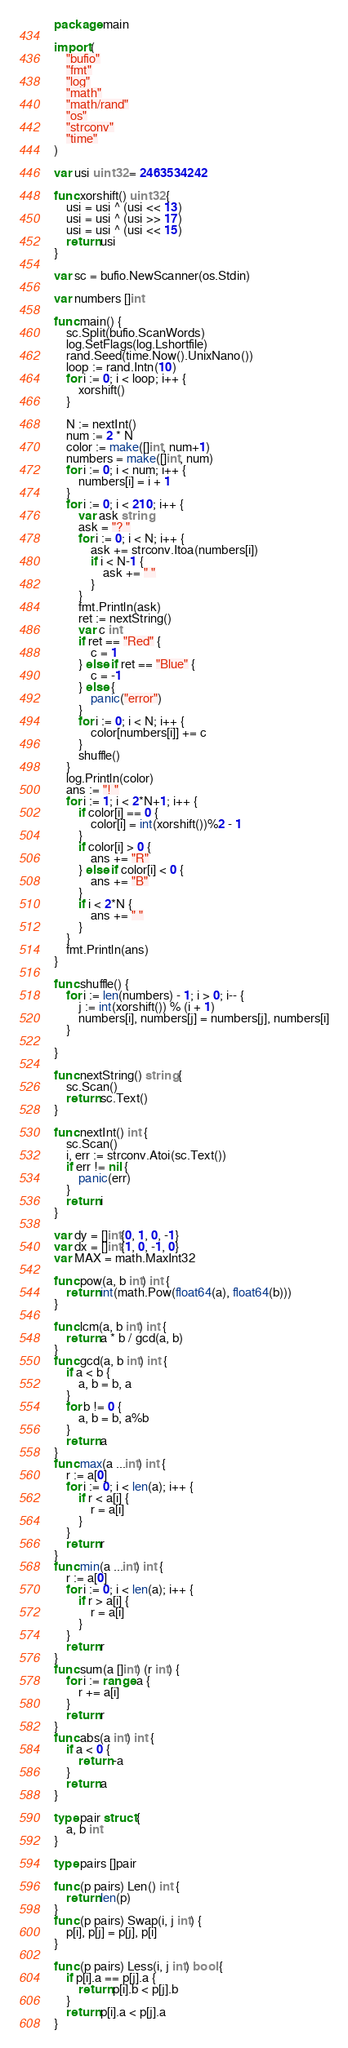Convert code to text. <code><loc_0><loc_0><loc_500><loc_500><_Go_>package main

import (
	"bufio"
	"fmt"
	"log"
	"math"
	"math/rand"
	"os"
	"strconv"
	"time"
)

var usi uint32 = 2463534242

func xorshift() uint32 {
	usi = usi ^ (usi << 13)
	usi = usi ^ (usi >> 17)
	usi = usi ^ (usi << 15)
	return usi
}

var sc = bufio.NewScanner(os.Stdin)

var numbers []int

func main() {
	sc.Split(bufio.ScanWords)
	log.SetFlags(log.Lshortfile)
	rand.Seed(time.Now().UnixNano())
	loop := rand.Intn(10)
	for i := 0; i < loop; i++ {
		xorshift()
	}

	N := nextInt()
	num := 2 * N
	color := make([]int, num+1)
	numbers = make([]int, num)
	for i := 0; i < num; i++ {
		numbers[i] = i + 1
	}
	for i := 0; i < 210; i++ {
		var ask string
		ask = "? "
		for i := 0; i < N; i++ {
			ask += strconv.Itoa(numbers[i])
			if i < N-1 {
				ask += " "
			}
		}
		fmt.Println(ask)
		ret := nextString()
		var c int
		if ret == "Red" {
			c = 1
		} else if ret == "Blue" {
			c = -1
		} else {
			panic("error")
		}
		for i := 0; i < N; i++ {
			color[numbers[i]] += c
		}
		shuffle()
	}
	log.Println(color)
	ans := "! "
	for i := 1; i < 2*N+1; i++ {
		if color[i] == 0 {
			color[i] = int(xorshift())%2 - 1
		}
		if color[i] > 0 {
			ans += "R"
		} else if color[i] < 0 {
			ans += "B"
		}
		if i < 2*N {
			ans += " "
		}
	}
	fmt.Println(ans)
}

func shuffle() {
	for i := len(numbers) - 1; i > 0; i-- {
		j := int(xorshift()) % (i + 1)
		numbers[i], numbers[j] = numbers[j], numbers[i]
	}

}

func nextString() string {
	sc.Scan()
	return sc.Text()
}

func nextInt() int {
	sc.Scan()
	i, err := strconv.Atoi(sc.Text())
	if err != nil {
		panic(err)
	}
	return i
}

var dy = []int{0, 1, 0, -1}
var dx = []int{1, 0, -1, 0}
var MAX = math.MaxInt32

func pow(a, b int) int {
	return int(math.Pow(float64(a), float64(b)))
}

func lcm(a, b int) int {
	return a * b / gcd(a, b)
}
func gcd(a, b int) int {
	if a < b {
		a, b = b, a
	}
	for b != 0 {
		a, b = b, a%b
	}
	return a
}
func max(a ...int) int {
	r := a[0]
	for i := 0; i < len(a); i++ {
		if r < a[i] {
			r = a[i]
		}
	}
	return r
}
func min(a ...int) int {
	r := a[0]
	for i := 0; i < len(a); i++ {
		if r > a[i] {
			r = a[i]
		}
	}
	return r
}
func sum(a []int) (r int) {
	for i := range a {
		r += a[i]
	}
	return r
}
func abs(a int) int {
	if a < 0 {
		return -a
	}
	return a
}

type pair struct {
	a, b int
}

type pairs []pair

func (p pairs) Len() int {
	return len(p)
}
func (p pairs) Swap(i, j int) {
	p[i], p[j] = p[j], p[i]
}

func (p pairs) Less(i, j int) bool {
	if p[i].a == p[j].a {
		return p[i].b < p[j].b
	}
	return p[i].a < p[j].a
}
</code> 